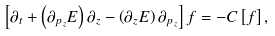Convert formula to latex. <formula><loc_0><loc_0><loc_500><loc_500>\left [ \partial _ { t } + \left ( \partial _ { p _ { z } } E \right ) \partial _ { z } - \left ( \partial _ { z } E \right ) \partial _ { p _ { z } } \right ] f = - C \left [ f \right ] ,</formula> 